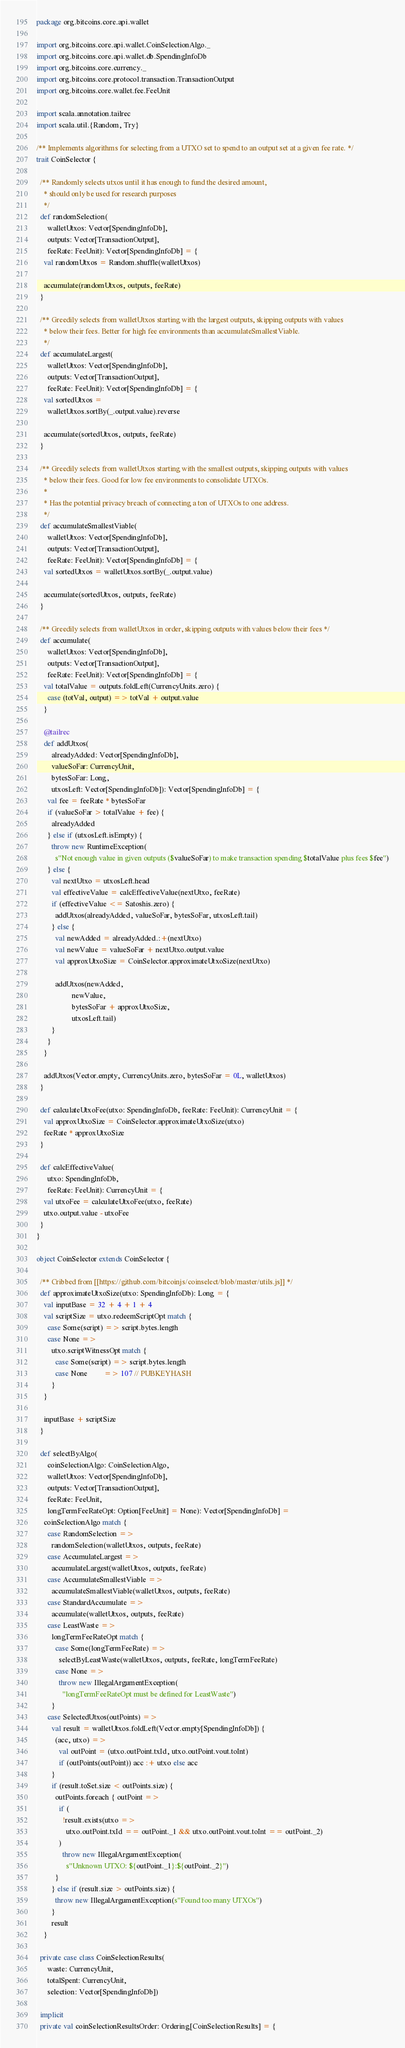<code> <loc_0><loc_0><loc_500><loc_500><_Scala_>package org.bitcoins.core.api.wallet

import org.bitcoins.core.api.wallet.CoinSelectionAlgo._
import org.bitcoins.core.api.wallet.db.SpendingInfoDb
import org.bitcoins.core.currency._
import org.bitcoins.core.protocol.transaction.TransactionOutput
import org.bitcoins.core.wallet.fee.FeeUnit

import scala.annotation.tailrec
import scala.util.{Random, Try}

/** Implements algorithms for selecting from a UTXO set to spend to an output set at a given fee rate. */
trait CoinSelector {

  /** Randomly selects utxos until it has enough to fund the desired amount,
    * should only be used for research purposes
    */
  def randomSelection(
      walletUtxos: Vector[SpendingInfoDb],
      outputs: Vector[TransactionOutput],
      feeRate: FeeUnit): Vector[SpendingInfoDb] = {
    val randomUtxos = Random.shuffle(walletUtxos)

    accumulate(randomUtxos, outputs, feeRate)
  }

  /** Greedily selects from walletUtxos starting with the largest outputs, skipping outputs with values
    * below their fees. Better for high fee environments than accumulateSmallestViable.
    */
  def accumulateLargest(
      walletUtxos: Vector[SpendingInfoDb],
      outputs: Vector[TransactionOutput],
      feeRate: FeeUnit): Vector[SpendingInfoDb] = {
    val sortedUtxos =
      walletUtxos.sortBy(_.output.value).reverse

    accumulate(sortedUtxos, outputs, feeRate)
  }

  /** Greedily selects from walletUtxos starting with the smallest outputs, skipping outputs with values
    * below their fees. Good for low fee environments to consolidate UTXOs.
    *
    * Has the potential privacy breach of connecting a ton of UTXOs to one address.
    */
  def accumulateSmallestViable(
      walletUtxos: Vector[SpendingInfoDb],
      outputs: Vector[TransactionOutput],
      feeRate: FeeUnit): Vector[SpendingInfoDb] = {
    val sortedUtxos = walletUtxos.sortBy(_.output.value)

    accumulate(sortedUtxos, outputs, feeRate)
  }

  /** Greedily selects from walletUtxos in order, skipping outputs with values below their fees */
  def accumulate(
      walletUtxos: Vector[SpendingInfoDb],
      outputs: Vector[TransactionOutput],
      feeRate: FeeUnit): Vector[SpendingInfoDb] = {
    val totalValue = outputs.foldLeft(CurrencyUnits.zero) {
      case (totVal, output) => totVal + output.value
    }

    @tailrec
    def addUtxos(
        alreadyAdded: Vector[SpendingInfoDb],
        valueSoFar: CurrencyUnit,
        bytesSoFar: Long,
        utxosLeft: Vector[SpendingInfoDb]): Vector[SpendingInfoDb] = {
      val fee = feeRate * bytesSoFar
      if (valueSoFar > totalValue + fee) {
        alreadyAdded
      } else if (utxosLeft.isEmpty) {
        throw new RuntimeException(
          s"Not enough value in given outputs ($valueSoFar) to make transaction spending $totalValue plus fees $fee")
      } else {
        val nextUtxo = utxosLeft.head
        val effectiveValue = calcEffectiveValue(nextUtxo, feeRate)
        if (effectiveValue <= Satoshis.zero) {
          addUtxos(alreadyAdded, valueSoFar, bytesSoFar, utxosLeft.tail)
        } else {
          val newAdded = alreadyAdded.:+(nextUtxo)
          val newValue = valueSoFar + nextUtxo.output.value
          val approxUtxoSize = CoinSelector.approximateUtxoSize(nextUtxo)

          addUtxos(newAdded,
                   newValue,
                   bytesSoFar + approxUtxoSize,
                   utxosLeft.tail)
        }
      }
    }

    addUtxos(Vector.empty, CurrencyUnits.zero, bytesSoFar = 0L, walletUtxos)
  }

  def calculateUtxoFee(utxo: SpendingInfoDb, feeRate: FeeUnit): CurrencyUnit = {
    val approxUtxoSize = CoinSelector.approximateUtxoSize(utxo)
    feeRate * approxUtxoSize
  }

  def calcEffectiveValue(
      utxo: SpendingInfoDb,
      feeRate: FeeUnit): CurrencyUnit = {
    val utxoFee = calculateUtxoFee(utxo, feeRate)
    utxo.output.value - utxoFee
  }
}

object CoinSelector extends CoinSelector {

  /** Cribbed from [[https://github.com/bitcoinjs/coinselect/blob/master/utils.js]] */
  def approximateUtxoSize(utxo: SpendingInfoDb): Long = {
    val inputBase = 32 + 4 + 1 + 4
    val scriptSize = utxo.redeemScriptOpt match {
      case Some(script) => script.bytes.length
      case None =>
        utxo.scriptWitnessOpt match {
          case Some(script) => script.bytes.length
          case None         => 107 // PUBKEYHASH
        }
    }

    inputBase + scriptSize
  }

  def selectByAlgo(
      coinSelectionAlgo: CoinSelectionAlgo,
      walletUtxos: Vector[SpendingInfoDb],
      outputs: Vector[TransactionOutput],
      feeRate: FeeUnit,
      longTermFeeRateOpt: Option[FeeUnit] = None): Vector[SpendingInfoDb] =
    coinSelectionAlgo match {
      case RandomSelection =>
        randomSelection(walletUtxos, outputs, feeRate)
      case AccumulateLargest =>
        accumulateLargest(walletUtxos, outputs, feeRate)
      case AccumulateSmallestViable =>
        accumulateSmallestViable(walletUtxos, outputs, feeRate)
      case StandardAccumulate =>
        accumulate(walletUtxos, outputs, feeRate)
      case LeastWaste =>
        longTermFeeRateOpt match {
          case Some(longTermFeeRate) =>
            selectByLeastWaste(walletUtxos, outputs, feeRate, longTermFeeRate)
          case None =>
            throw new IllegalArgumentException(
              "longTermFeeRateOpt must be defined for LeastWaste")
        }
      case SelectedUtxos(outPoints) =>
        val result = walletUtxos.foldLeft(Vector.empty[SpendingInfoDb]) {
          (acc, utxo) =>
            val outPoint = (utxo.outPoint.txId, utxo.outPoint.vout.toInt)
            if (outPoints(outPoint)) acc :+ utxo else acc
        }
        if (result.toSet.size < outPoints.size) {
          outPoints.foreach { outPoint =>
            if (
              !result.exists(utxo =>
                utxo.outPoint.txId == outPoint._1 && utxo.outPoint.vout.toInt == outPoint._2)
            )
              throw new IllegalArgumentException(
                s"Unknown UTXO: ${outPoint._1}:${outPoint._2}")
          }
        } else if (result.size > outPoints.size) {
          throw new IllegalArgumentException(s"Found too many UTXOs")
        }
        result
    }

  private case class CoinSelectionResults(
      waste: CurrencyUnit,
      totalSpent: CurrencyUnit,
      selection: Vector[SpendingInfoDb])

  implicit
  private val coinSelectionResultsOrder: Ordering[CoinSelectionResults] = {</code> 